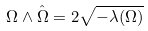<formula> <loc_0><loc_0><loc_500><loc_500>\Omega \wedge \hat { \Omega } = 2 \sqrt { - \lambda ( \Omega ) }</formula> 